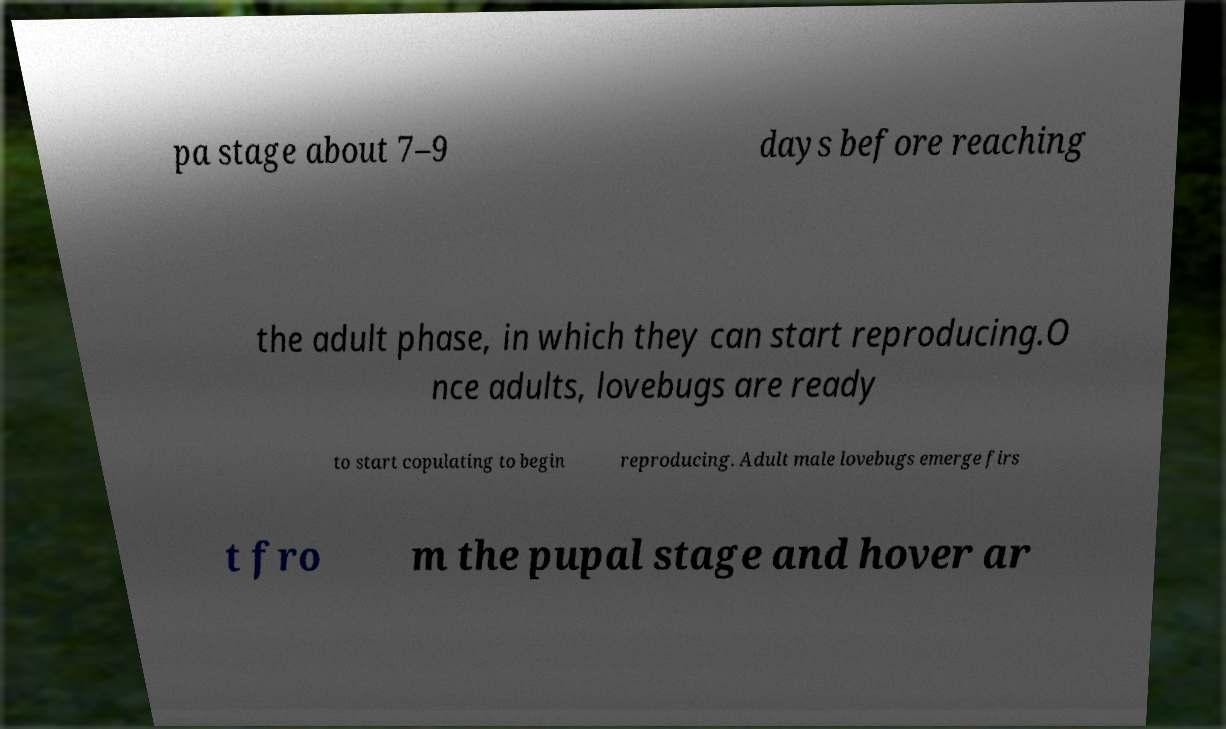Please read and relay the text visible in this image. What does it say? pa stage about 7–9 days before reaching the adult phase, in which they can start reproducing.O nce adults, lovebugs are ready to start copulating to begin reproducing. Adult male lovebugs emerge firs t fro m the pupal stage and hover ar 